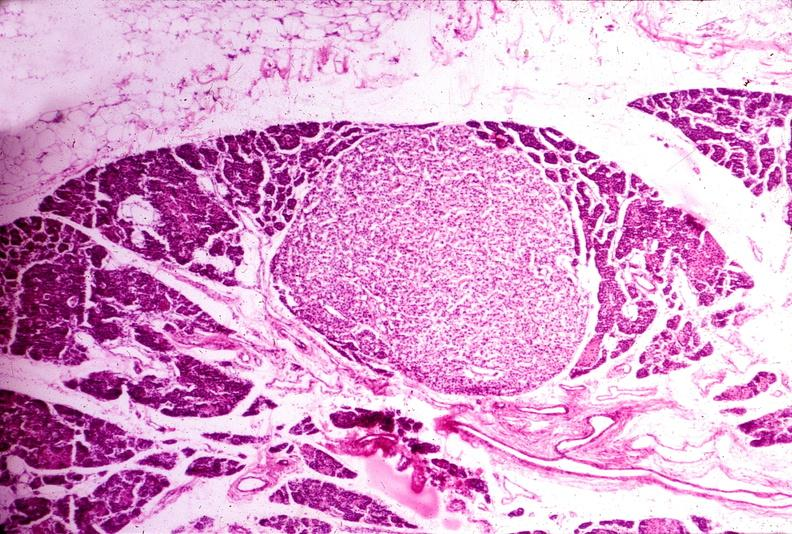s papillary intraductal adenocarcinoma present?
Answer the question using a single word or phrase. No 